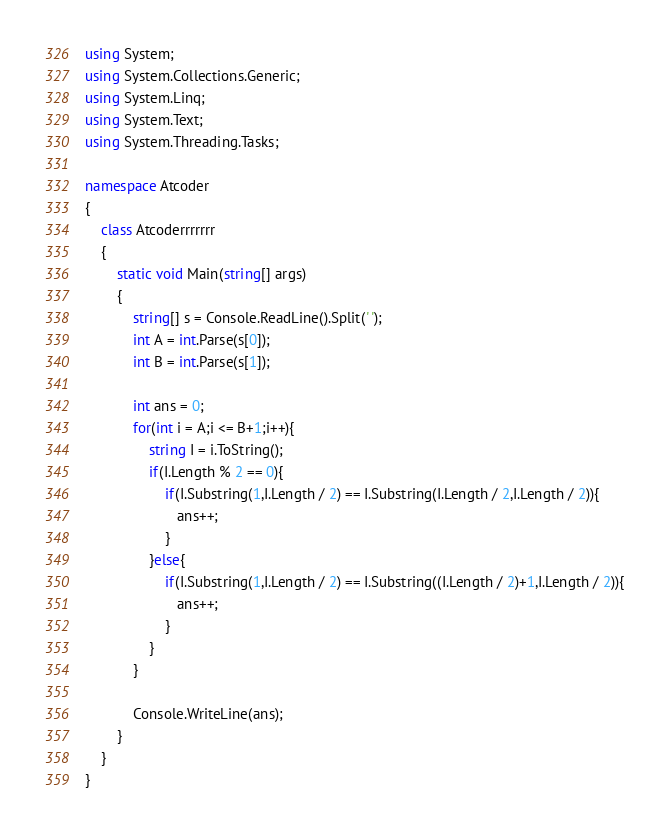Convert code to text. <code><loc_0><loc_0><loc_500><loc_500><_C#_>using System;
using System.Collections.Generic;
using System.Linq;
using System.Text;
using System.Threading.Tasks;

namespace Atcoder
{
    class Atcoderrrrrrr
    {
        static void Main(string[] args)
        {
            string[] s = Console.ReadLine().Split(' ');
            int A = int.Parse(s[0]);
            int B = int.Parse(s[1]);

            int ans = 0;
            for(int i = A;i <= B+1;i++){
                string I = i.ToString();
                if(I.Length % 2 == 0){
                    if(I.Substring(1,I.Length / 2) == I.Substring(I.Length / 2,I.Length / 2)){
                       ans++; 
                    }
                }else{
                    if(I.Substring(1,I.Length / 2) == I.Substring((I.Length / 2)+1,I.Length / 2)){
                       ans++;
                    }
                }   
            }

            Console.WriteLine(ans);
        }
    }
}
</code> 